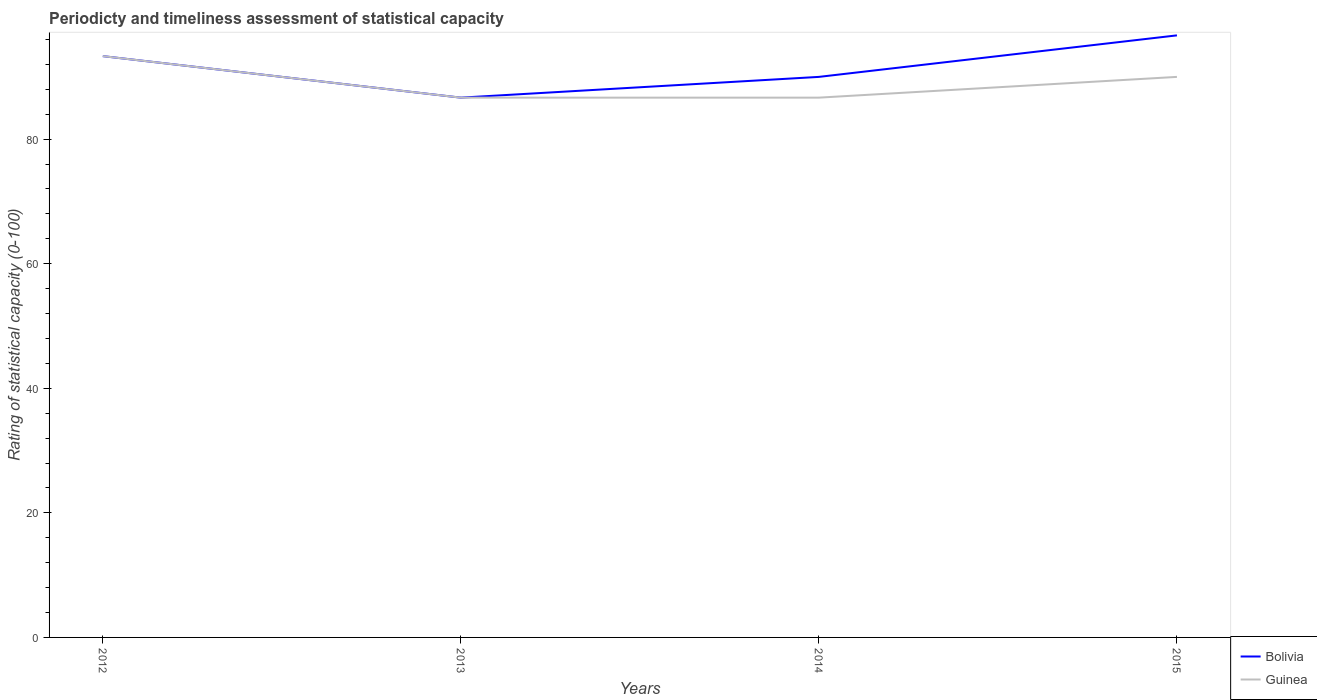How many different coloured lines are there?
Provide a succinct answer. 2. Across all years, what is the maximum rating of statistical capacity in Guinea?
Offer a terse response. 86.67. In which year was the rating of statistical capacity in Bolivia maximum?
Offer a very short reply. 2013. What is the difference between the highest and the second highest rating of statistical capacity in Bolivia?
Ensure brevity in your answer.  10. Is the rating of statistical capacity in Bolivia strictly greater than the rating of statistical capacity in Guinea over the years?
Ensure brevity in your answer.  No. Are the values on the major ticks of Y-axis written in scientific E-notation?
Provide a succinct answer. No. Does the graph contain grids?
Make the answer very short. No. How many legend labels are there?
Offer a very short reply. 2. What is the title of the graph?
Offer a very short reply. Periodicty and timeliness assessment of statistical capacity. What is the label or title of the Y-axis?
Offer a terse response. Rating of statistical capacity (0-100). What is the Rating of statistical capacity (0-100) in Bolivia in 2012?
Provide a succinct answer. 93.33. What is the Rating of statistical capacity (0-100) in Guinea in 2012?
Keep it short and to the point. 93.33. What is the Rating of statistical capacity (0-100) of Bolivia in 2013?
Make the answer very short. 86.67. What is the Rating of statistical capacity (0-100) of Guinea in 2013?
Your response must be concise. 86.67. What is the Rating of statistical capacity (0-100) in Guinea in 2014?
Offer a terse response. 86.67. What is the Rating of statistical capacity (0-100) of Bolivia in 2015?
Keep it short and to the point. 96.67. What is the Rating of statistical capacity (0-100) in Guinea in 2015?
Make the answer very short. 90. Across all years, what is the maximum Rating of statistical capacity (0-100) of Bolivia?
Make the answer very short. 96.67. Across all years, what is the maximum Rating of statistical capacity (0-100) of Guinea?
Provide a succinct answer. 93.33. Across all years, what is the minimum Rating of statistical capacity (0-100) in Bolivia?
Your answer should be compact. 86.67. Across all years, what is the minimum Rating of statistical capacity (0-100) in Guinea?
Give a very brief answer. 86.67. What is the total Rating of statistical capacity (0-100) in Bolivia in the graph?
Make the answer very short. 366.67. What is the total Rating of statistical capacity (0-100) of Guinea in the graph?
Offer a very short reply. 356.67. What is the difference between the Rating of statistical capacity (0-100) in Guinea in 2012 and that in 2013?
Provide a succinct answer. 6.67. What is the difference between the Rating of statistical capacity (0-100) of Bolivia in 2012 and that in 2014?
Your answer should be compact. 3.33. What is the difference between the Rating of statistical capacity (0-100) in Guinea in 2012 and that in 2014?
Provide a short and direct response. 6.67. What is the difference between the Rating of statistical capacity (0-100) in Bolivia in 2012 and that in 2015?
Provide a succinct answer. -3.33. What is the difference between the Rating of statistical capacity (0-100) in Guinea in 2013 and that in 2014?
Your response must be concise. 0. What is the difference between the Rating of statistical capacity (0-100) in Bolivia in 2013 and that in 2015?
Provide a succinct answer. -10. What is the difference between the Rating of statistical capacity (0-100) in Bolivia in 2014 and that in 2015?
Provide a succinct answer. -6.67. What is the difference between the Rating of statistical capacity (0-100) in Guinea in 2014 and that in 2015?
Your response must be concise. -3.33. What is the difference between the Rating of statistical capacity (0-100) of Bolivia in 2012 and the Rating of statistical capacity (0-100) of Guinea in 2013?
Your response must be concise. 6.67. What is the difference between the Rating of statistical capacity (0-100) of Bolivia in 2012 and the Rating of statistical capacity (0-100) of Guinea in 2014?
Offer a terse response. 6.67. What is the average Rating of statistical capacity (0-100) in Bolivia per year?
Ensure brevity in your answer.  91.67. What is the average Rating of statistical capacity (0-100) of Guinea per year?
Your answer should be compact. 89.17. In the year 2012, what is the difference between the Rating of statistical capacity (0-100) of Bolivia and Rating of statistical capacity (0-100) of Guinea?
Ensure brevity in your answer.  0. In the year 2014, what is the difference between the Rating of statistical capacity (0-100) in Bolivia and Rating of statistical capacity (0-100) in Guinea?
Your response must be concise. 3.33. What is the ratio of the Rating of statistical capacity (0-100) in Bolivia in 2012 to that in 2013?
Provide a short and direct response. 1.08. What is the ratio of the Rating of statistical capacity (0-100) of Guinea in 2012 to that in 2013?
Your response must be concise. 1.08. What is the ratio of the Rating of statistical capacity (0-100) in Bolivia in 2012 to that in 2014?
Your answer should be very brief. 1.04. What is the ratio of the Rating of statistical capacity (0-100) in Bolivia in 2012 to that in 2015?
Your answer should be very brief. 0.97. What is the ratio of the Rating of statistical capacity (0-100) in Bolivia in 2013 to that in 2014?
Keep it short and to the point. 0.96. What is the ratio of the Rating of statistical capacity (0-100) in Guinea in 2013 to that in 2014?
Your response must be concise. 1. What is the ratio of the Rating of statistical capacity (0-100) of Bolivia in 2013 to that in 2015?
Offer a terse response. 0.9. What is the difference between the highest and the second highest Rating of statistical capacity (0-100) in Bolivia?
Ensure brevity in your answer.  3.33. What is the difference between the highest and the second highest Rating of statistical capacity (0-100) in Guinea?
Give a very brief answer. 3.33. What is the difference between the highest and the lowest Rating of statistical capacity (0-100) in Bolivia?
Give a very brief answer. 10. 